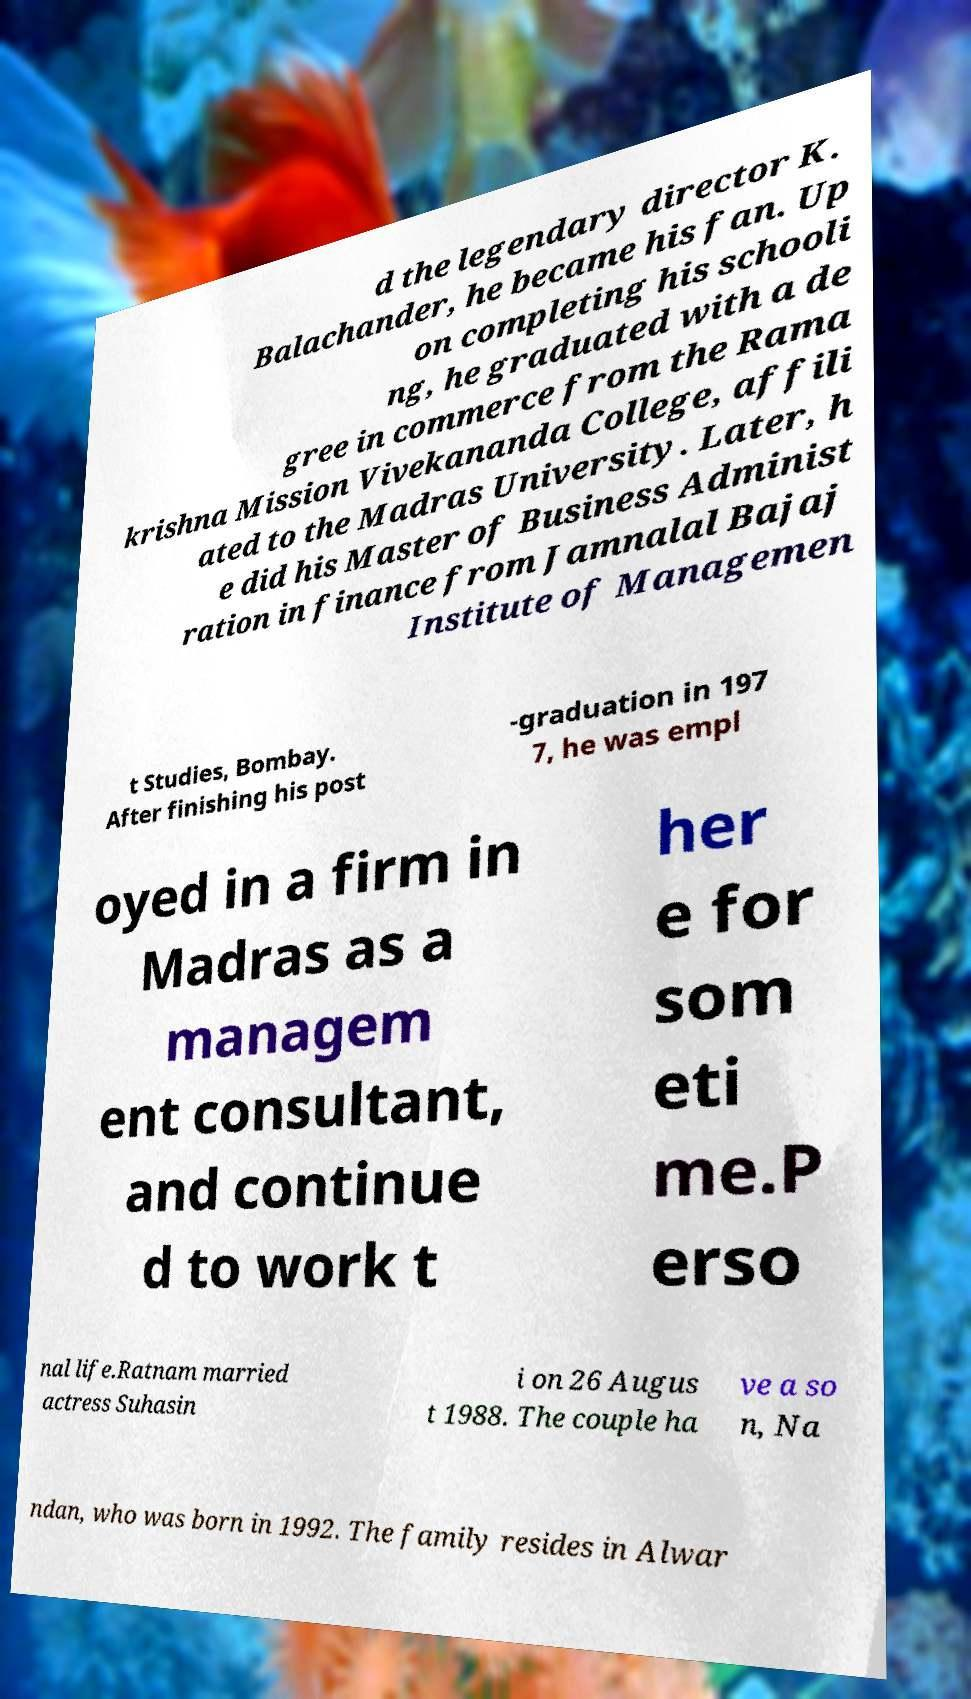Could you extract and type out the text from this image? d the legendary director K. Balachander, he became his fan. Up on completing his schooli ng, he graduated with a de gree in commerce from the Rama krishna Mission Vivekananda College, affili ated to the Madras University. Later, h e did his Master of Business Administ ration in finance from Jamnalal Bajaj Institute of Managemen t Studies, Bombay. After finishing his post -graduation in 197 7, he was empl oyed in a firm in Madras as a managem ent consultant, and continue d to work t her e for som eti me.P erso nal life.Ratnam married actress Suhasin i on 26 Augus t 1988. The couple ha ve a so n, Na ndan, who was born in 1992. The family resides in Alwar 